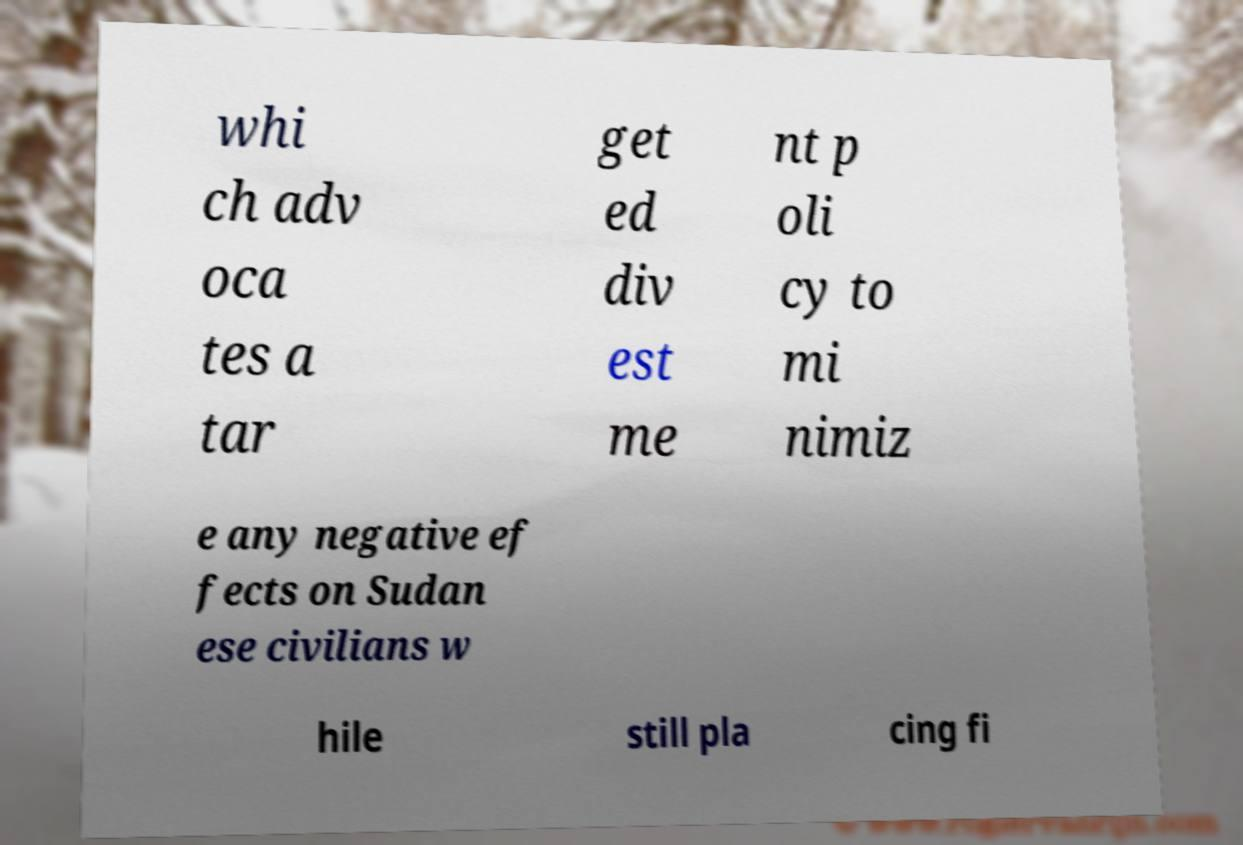There's text embedded in this image that I need extracted. Can you transcribe it verbatim? whi ch adv oca tes a tar get ed div est me nt p oli cy to mi nimiz e any negative ef fects on Sudan ese civilians w hile still pla cing fi 